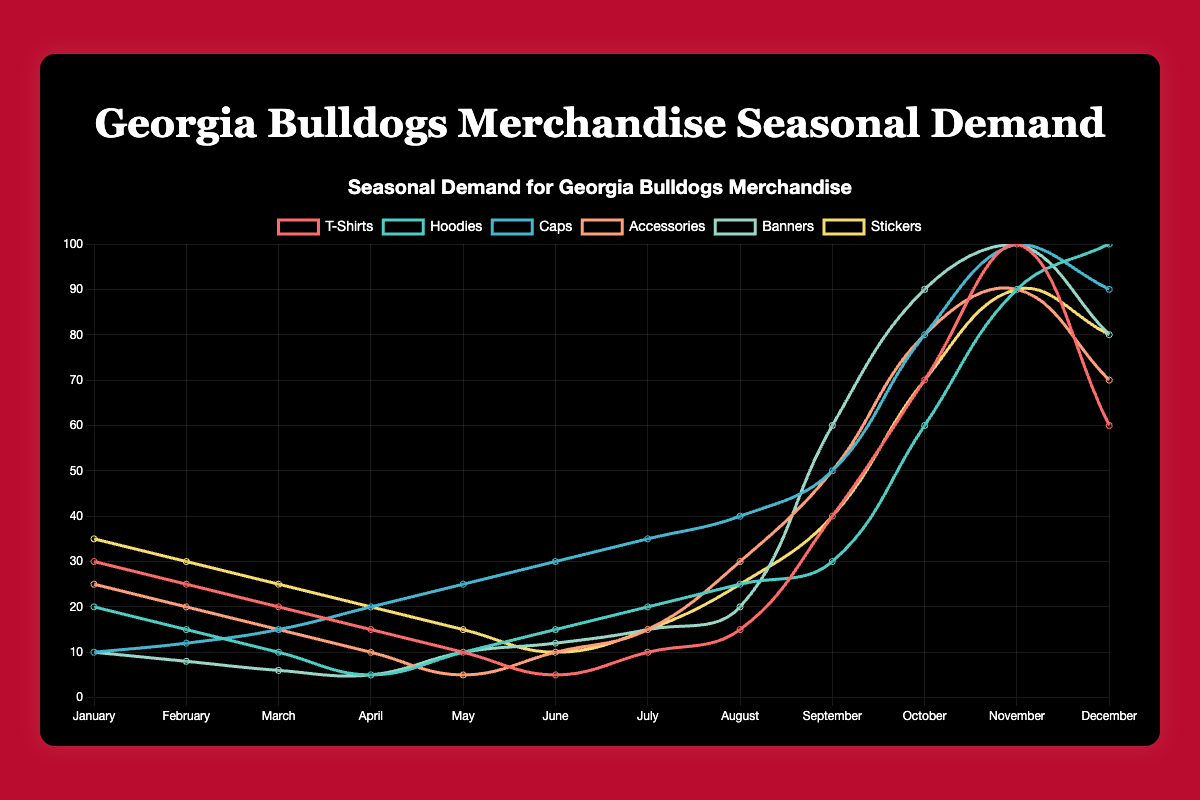Which merchandise type has the highest demand in December? In the December data, the demand for Hoodies is highest at 100 units, followed by Banners and Caps.
Answer: Hoodies Which merchandise type has the lowest demand in June? Looking at the June data, T-Shirts have the lowest demand at 5 units. Other items have higher values.
Answer: T-Shirts What is the average demand for Hoodies across the year? Adding up all monthly demands for Hoodies (20 + 15 + 10 + 5 + 10 + 15 + 20 + 25 + 30 + 60 + 90 + 100) gives a total of 400 units. Dividing by 12 months, the average is 400/12 ≈ 33.33
Answer: 33.33 In which month is the demand for T-Shirts exactly equal to the demand for Hoodies? The demand for T-Shirts is equal to Hoodies in both May and August where the demand for both types is 10 and 25 units, respectively.
Answer: May and August Which type of merchandise shows the most significant peak in October? In October, T-Shirts see the most significant peak with a demand of 70 units compared to previous months.
Answer: T-Shirts Which merchandise type has the most uniform demand throughout the year? Hoodies show a relatively uniform and gradual increase in demand over the year, starting from 20 units in January to 100 in December, as opposed to large fluctuations seen in others.
Answer: Hoodies How much higher is the demand for Stickers than Banners in November? In November, Stickers have a demand of 90 units, whereas Banners have 100 units. The difference is 90 - 100 = -10, indicating that Stickers have 10 units less demand than Banners.
Answer: 10 units less Which month has the highest aggregate demand across all merchandise types? Summing the demands across all merchandise types for each month, October has the highest aggregate demand (70+60+80+80+100+70 = 460).
Answer: October In looking at Accessories, which two consecutive months show the largest increase in demand? Adding up the increases between consecutive months, the largest increase for Accessories is between August (30) and September (50), a difference of 20 units.
Answer: August to September Comparing November, which type of merchandise has the second-highest demand? In November, Banners have the highest demand at 100 units, followed by Hoodies with 90 units.
Answer: Hoodies 